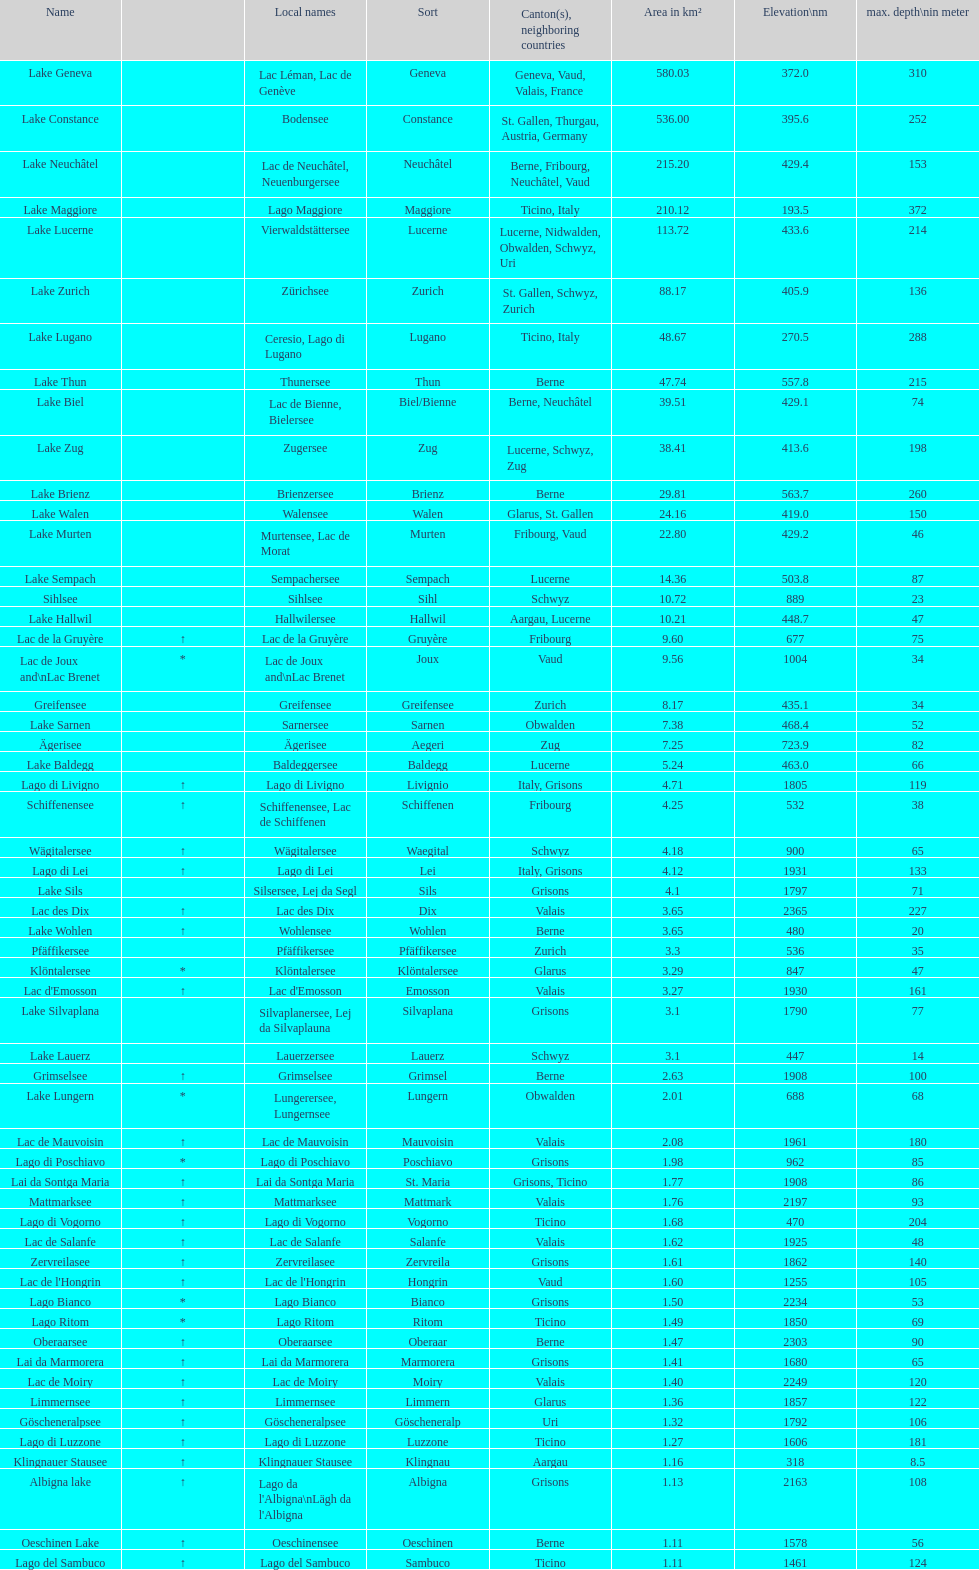Write the full table. {'header': ['Name', '', 'Local names', 'Sort', 'Canton(s), neighboring countries', 'Area in km²', 'Elevation\\nm', 'max. depth\\nin meter'], 'rows': [['Lake Geneva', '', 'Lac Léman, Lac de Genève', 'Geneva', 'Geneva, Vaud, Valais, France', '580.03', '372.0', '310'], ['Lake Constance', '', 'Bodensee', 'Constance', 'St. Gallen, Thurgau, Austria, Germany', '536.00', '395.6', '252'], ['Lake Neuchâtel', '', 'Lac de Neuchâtel, Neuenburgersee', 'Neuchâtel', 'Berne, Fribourg, Neuchâtel, Vaud', '215.20', '429.4', '153'], ['Lake Maggiore', '', 'Lago Maggiore', 'Maggiore', 'Ticino, Italy', '210.12', '193.5', '372'], ['Lake Lucerne', '', 'Vierwaldstättersee', 'Lucerne', 'Lucerne, Nidwalden, Obwalden, Schwyz, Uri', '113.72', '433.6', '214'], ['Lake Zurich', '', 'Zürichsee', 'Zurich', 'St. Gallen, Schwyz, Zurich', '88.17', '405.9', '136'], ['Lake Lugano', '', 'Ceresio, Lago di Lugano', 'Lugano', 'Ticino, Italy', '48.67', '270.5', '288'], ['Lake Thun', '', 'Thunersee', 'Thun', 'Berne', '47.74', '557.8', '215'], ['Lake Biel', '', 'Lac de Bienne, Bielersee', 'Biel/Bienne', 'Berne, Neuchâtel', '39.51', '429.1', '74'], ['Lake Zug', '', 'Zugersee', 'Zug', 'Lucerne, Schwyz, Zug', '38.41', '413.6', '198'], ['Lake Brienz', '', 'Brienzersee', 'Brienz', 'Berne', '29.81', '563.7', '260'], ['Lake Walen', '', 'Walensee', 'Walen', 'Glarus, St. Gallen', '24.16', '419.0', '150'], ['Lake Murten', '', 'Murtensee, Lac de Morat', 'Murten', 'Fribourg, Vaud', '22.80', '429.2', '46'], ['Lake Sempach', '', 'Sempachersee', 'Sempach', 'Lucerne', '14.36', '503.8', '87'], ['Sihlsee', '', 'Sihlsee', 'Sihl', 'Schwyz', '10.72', '889', '23'], ['Lake Hallwil', '', 'Hallwilersee', 'Hallwil', 'Aargau, Lucerne', '10.21', '448.7', '47'], ['Lac de la Gruyère', '↑', 'Lac de la Gruyère', 'Gruyère', 'Fribourg', '9.60', '677', '75'], ['Lac de Joux and\\nLac Brenet', '*', 'Lac de Joux and\\nLac Brenet', 'Joux', 'Vaud', '9.56', '1004', '34'], ['Greifensee', '', 'Greifensee', 'Greifensee', 'Zurich', '8.17', '435.1', '34'], ['Lake Sarnen', '', 'Sarnersee', 'Sarnen', 'Obwalden', '7.38', '468.4', '52'], ['Ägerisee', '', 'Ägerisee', 'Aegeri', 'Zug', '7.25', '723.9', '82'], ['Lake Baldegg', '', 'Baldeggersee', 'Baldegg', 'Lucerne', '5.24', '463.0', '66'], ['Lago di Livigno', '↑', 'Lago di Livigno', 'Livignio', 'Italy, Grisons', '4.71', '1805', '119'], ['Schiffenensee', '↑', 'Schiffenensee, Lac de Schiffenen', 'Schiffenen', 'Fribourg', '4.25', '532', '38'], ['Wägitalersee', '↑', 'Wägitalersee', 'Waegital', 'Schwyz', '4.18', '900', '65'], ['Lago di Lei', '↑', 'Lago di Lei', 'Lei', 'Italy, Grisons', '4.12', '1931', '133'], ['Lake Sils', '', 'Silsersee, Lej da Segl', 'Sils', 'Grisons', '4.1', '1797', '71'], ['Lac des Dix', '↑', 'Lac des Dix', 'Dix', 'Valais', '3.65', '2365', '227'], ['Lake Wohlen', '↑', 'Wohlensee', 'Wohlen', 'Berne', '3.65', '480', '20'], ['Pfäffikersee', '', 'Pfäffikersee', 'Pfäffikersee', 'Zurich', '3.3', '536', '35'], ['Klöntalersee', '*', 'Klöntalersee', 'Klöntalersee', 'Glarus', '3.29', '847', '47'], ["Lac d'Emosson", '↑', "Lac d'Emosson", 'Emosson', 'Valais', '3.27', '1930', '161'], ['Lake Silvaplana', '', 'Silvaplanersee, Lej da Silvaplauna', 'Silvaplana', 'Grisons', '3.1', '1790', '77'], ['Lake Lauerz', '', 'Lauerzersee', 'Lauerz', 'Schwyz', '3.1', '447', '14'], ['Grimselsee', '↑', 'Grimselsee', 'Grimsel', 'Berne', '2.63', '1908', '100'], ['Lake Lungern', '*', 'Lungerersee, Lungernsee', 'Lungern', 'Obwalden', '2.01', '688', '68'], ['Lac de Mauvoisin', '↑', 'Lac de Mauvoisin', 'Mauvoisin', 'Valais', '2.08', '1961', '180'], ['Lago di Poschiavo', '*', 'Lago di Poschiavo', 'Poschiavo', 'Grisons', '1.98', '962', '85'], ['Lai da Sontga Maria', '↑', 'Lai da Sontga Maria', 'St. Maria', 'Grisons, Ticino', '1.77', '1908', '86'], ['Mattmarksee', '↑', 'Mattmarksee', 'Mattmark', 'Valais', '1.76', '2197', '93'], ['Lago di Vogorno', '↑', 'Lago di Vogorno', 'Vogorno', 'Ticino', '1.68', '470', '204'], ['Lac de Salanfe', '↑', 'Lac de Salanfe', 'Salanfe', 'Valais', '1.62', '1925', '48'], ['Zervreilasee', '↑', 'Zervreilasee', 'Zervreila', 'Grisons', '1.61', '1862', '140'], ["Lac de l'Hongrin", '↑', "Lac de l'Hongrin", 'Hongrin', 'Vaud', '1.60', '1255', '105'], ['Lago Bianco', '*', 'Lago Bianco', 'Bianco', 'Grisons', '1.50', '2234', '53'], ['Lago Ritom', '*', 'Lago Ritom', 'Ritom', 'Ticino', '1.49', '1850', '69'], ['Oberaarsee', '↑', 'Oberaarsee', 'Oberaar', 'Berne', '1.47', '2303', '90'], ['Lai da Marmorera', '↑', 'Lai da Marmorera', 'Marmorera', 'Grisons', '1.41', '1680', '65'], ['Lac de Moiry', '↑', 'Lac de Moiry', 'Moiry', 'Valais', '1.40', '2249', '120'], ['Limmernsee', '↑', 'Limmernsee', 'Limmern', 'Glarus', '1.36', '1857', '122'], ['Göscheneralpsee', '↑', 'Göscheneralpsee', 'Göscheneralp', 'Uri', '1.32', '1792', '106'], ['Lago di Luzzone', '↑', 'Lago di Luzzone', 'Luzzone', 'Ticino', '1.27', '1606', '181'], ['Klingnauer Stausee', '↑', 'Klingnauer Stausee', 'Klingnau', 'Aargau', '1.16', '318', '8.5'], ['Albigna lake', '↑', "Lago da l'Albigna\\nLägh da l'Albigna", 'Albigna', 'Grisons', '1.13', '2163', '108'], ['Oeschinen Lake', '↑', 'Oeschinensee', 'Oeschinen', 'Berne', '1.11', '1578', '56'], ['Lago del Sambuco', '↑', 'Lago del Sambuco', 'Sambuco', 'Ticino', '1.11', '1461', '124']]} Which lake has the next highest height after lac des dix? Oberaarsee. 